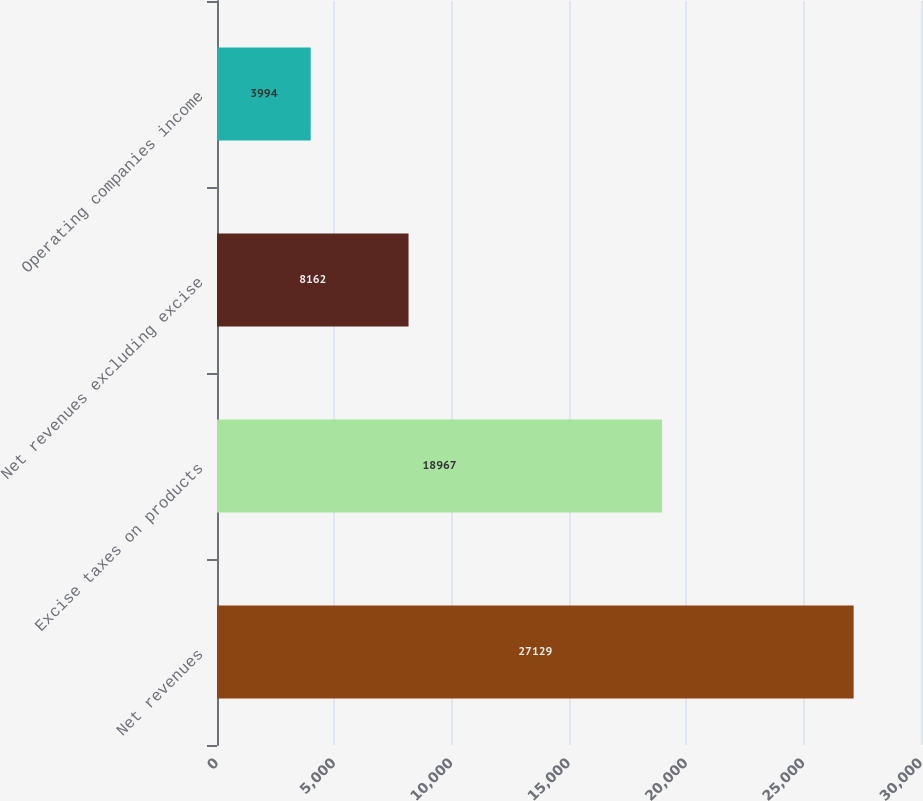Convert chart to OTSL. <chart><loc_0><loc_0><loc_500><loc_500><bar_chart><fcel>Net revenues<fcel>Excise taxes on products<fcel>Net revenues excluding excise<fcel>Operating companies income<nl><fcel>27129<fcel>18967<fcel>8162<fcel>3994<nl></chart> 